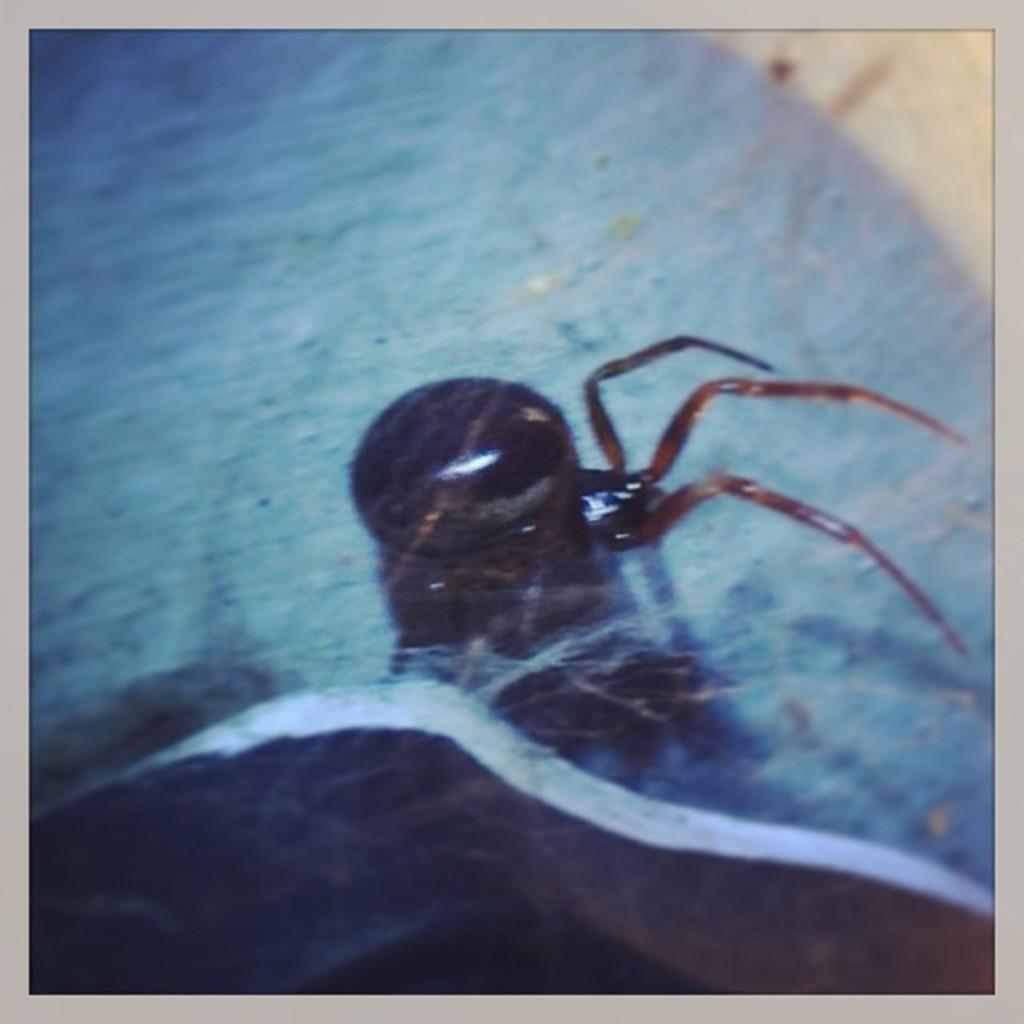In one or two sentences, can you explain what this image depicts? In this image we can see an insect. 